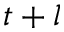<formula> <loc_0><loc_0><loc_500><loc_500>t + l</formula> 